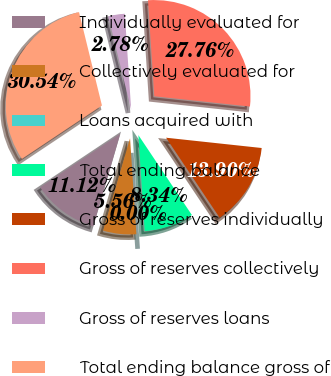<chart> <loc_0><loc_0><loc_500><loc_500><pie_chart><fcel>Individually evaluated for<fcel>Collectively evaluated for<fcel>Loans acquired with<fcel>Total ending balance<fcel>Gross of reserves individually<fcel>Gross of reserves collectively<fcel>Gross of reserves loans<fcel>Total ending balance gross of<nl><fcel>11.12%<fcel>5.56%<fcel>0.0%<fcel>8.34%<fcel>13.9%<fcel>27.75%<fcel>2.78%<fcel>30.53%<nl></chart> 